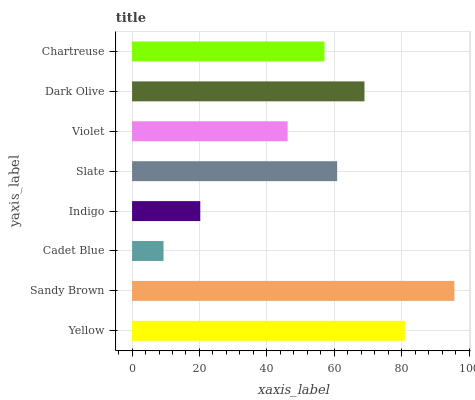Is Cadet Blue the minimum?
Answer yes or no. Yes. Is Sandy Brown the maximum?
Answer yes or no. Yes. Is Sandy Brown the minimum?
Answer yes or no. No. Is Cadet Blue the maximum?
Answer yes or no. No. Is Sandy Brown greater than Cadet Blue?
Answer yes or no. Yes. Is Cadet Blue less than Sandy Brown?
Answer yes or no. Yes. Is Cadet Blue greater than Sandy Brown?
Answer yes or no. No. Is Sandy Brown less than Cadet Blue?
Answer yes or no. No. Is Slate the high median?
Answer yes or no. Yes. Is Chartreuse the low median?
Answer yes or no. Yes. Is Dark Olive the high median?
Answer yes or no. No. Is Dark Olive the low median?
Answer yes or no. No. 